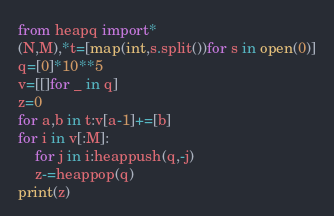Convert code to text. <code><loc_0><loc_0><loc_500><loc_500><_Python_>from heapq import*
(N,M),*t=[map(int,s.split())for s in open(0)]
q=[0]*10**5
v=[[]for _ in q]
z=0
for a,b in t:v[a-1]+=[b]
for i in v[:M]:
	for j in i:heappush(q,-j)
	z-=heappop(q)
print(z)</code> 